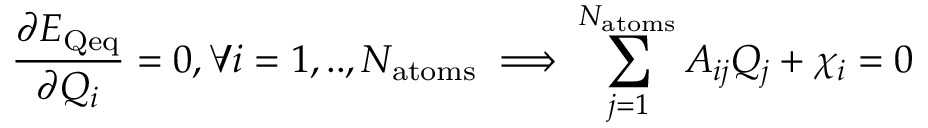Convert formula to latex. <formula><loc_0><loc_0><loc_500><loc_500>\frac { \partial E _ { Q e q } } { \partial Q _ { i } } = 0 , \forall i = 1 , . . , N _ { a t o m s } \implies \sum _ { j = 1 } ^ { N _ { a t o m s } } A _ { i j } Q _ { j } + \chi _ { i } = 0</formula> 